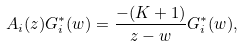Convert formula to latex. <formula><loc_0><loc_0><loc_500><loc_500>A _ { i } ( z ) G ^ { \ast } _ { i } ( w ) = \frac { - ( K + 1 ) } { z - w } G ^ { \ast } _ { i } ( w ) ,</formula> 